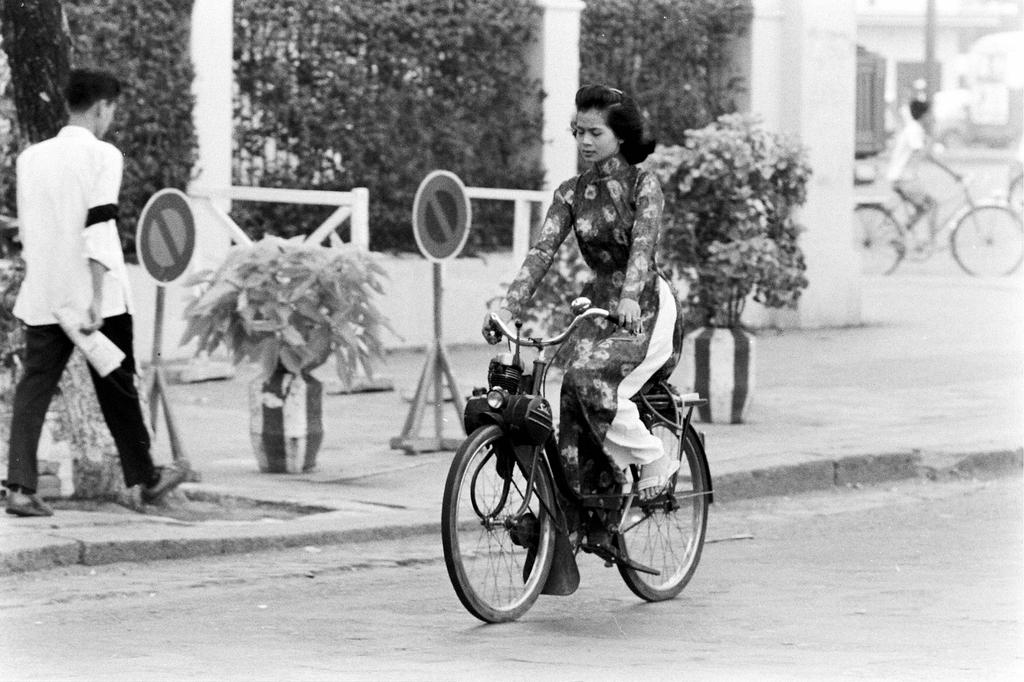What is the woman doing in the image? The woman is riding a bicycle in the image. What is the man doing in the image? The man is walking on a path in the image. What can be seen in the background of the image? There are plants and trees in the background of the image. What type of chalk is the woman using to draw on the road in the image? There is no chalk or road present in the image; the woman is riding a bicycle, and the man is walking on a path. 